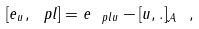<formula> <loc_0><loc_0><loc_500><loc_500>[ e _ { u } , \ p l ] = e _ { \ p l u } - [ u , . ] _ { \mathcal { A } } \ ,</formula> 